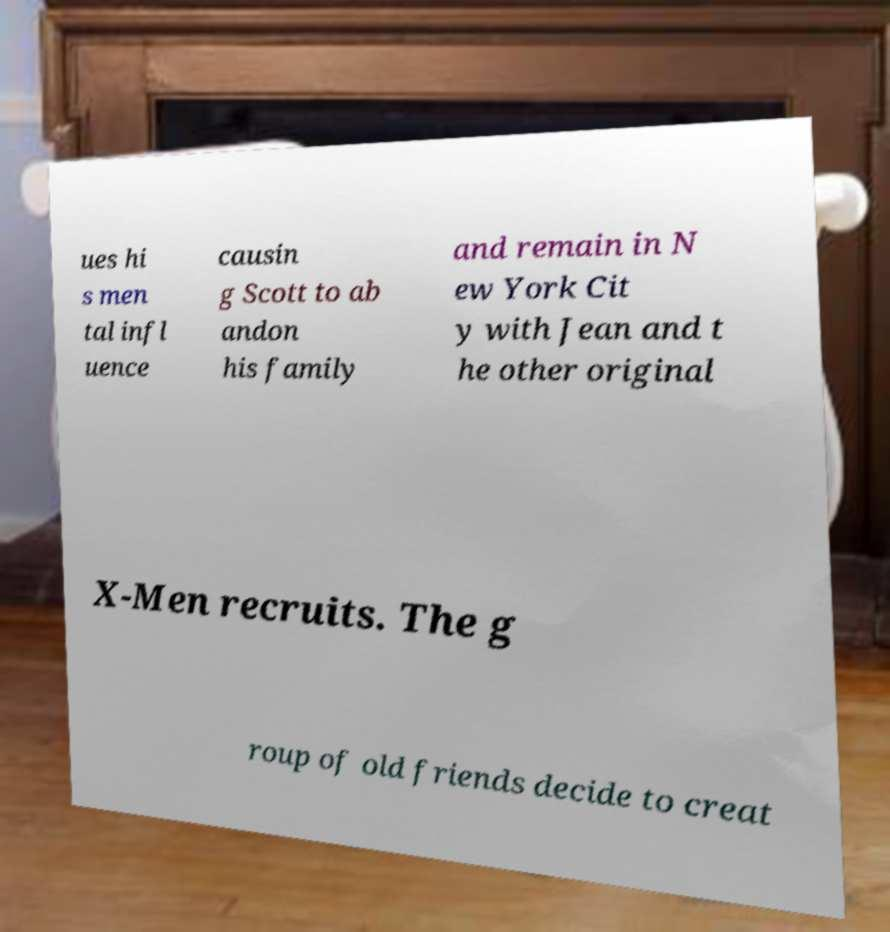I need the written content from this picture converted into text. Can you do that? ues hi s men tal infl uence causin g Scott to ab andon his family and remain in N ew York Cit y with Jean and t he other original X-Men recruits. The g roup of old friends decide to creat 